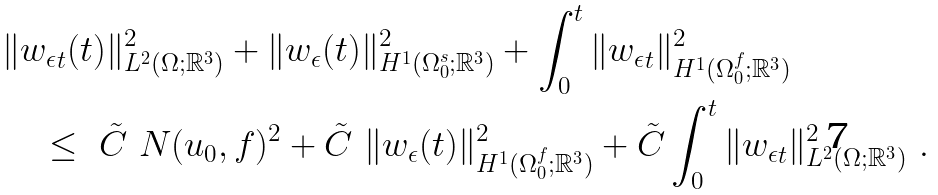Convert formula to latex. <formula><loc_0><loc_0><loc_500><loc_500>& \| { w _ { \epsilon } } _ { t } ( t ) \| ^ { 2 } _ { L ^ { 2 } ( \Omega ; { \mathbb { R } } ^ { 3 } ) } + \| { w _ { \epsilon } } ( t ) \| ^ { 2 } _ { H ^ { 1 } ( \Omega _ { 0 } ^ { s } ; { \mathbb { R } } ^ { 3 } ) } + \int _ { 0 } ^ { t } \| { w _ { \epsilon } } _ { t } \| ^ { 2 } _ { H ^ { 1 } ( \Omega _ { 0 } ^ { f } ; { \mathbb { R } } ^ { 3 } ) } \\ & \quad \leq \ \tilde { C } \ N ( u _ { 0 } , f ) ^ { 2 } + \tilde { C } \ \| { w _ { \epsilon } } ( t ) \| ^ { 2 } _ { H ^ { 1 } ( \Omega _ { 0 } ^ { f } ; { \mathbb { R } } ^ { 3 } ) } + \tilde { C } \int _ { 0 } ^ { t } \| { w _ { \epsilon } } _ { t } \| ^ { 2 } _ { L ^ { 2 } ( \Omega ; { \mathbb { R } } ^ { 3 } ) } \ .</formula> 